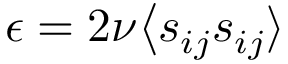<formula> <loc_0><loc_0><loc_500><loc_500>\epsilon = 2 \nu \Big \langle s _ { i j } s _ { i j } \rangle</formula> 